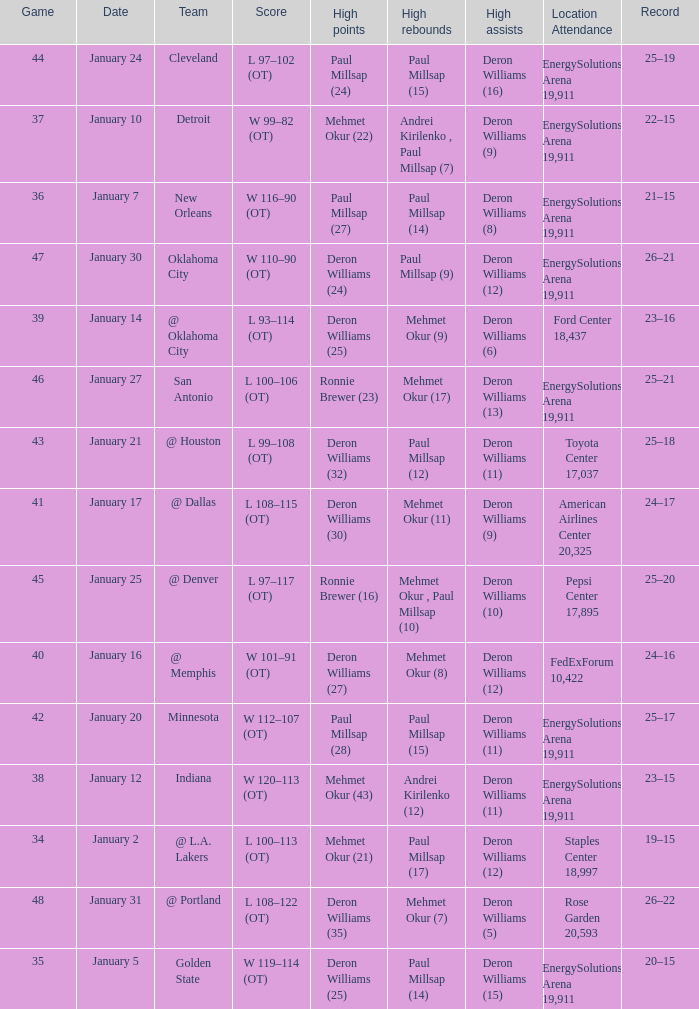Who had the high rebounds of the game that Deron Williams (5) had the high assists? Mehmet Okur (7). 